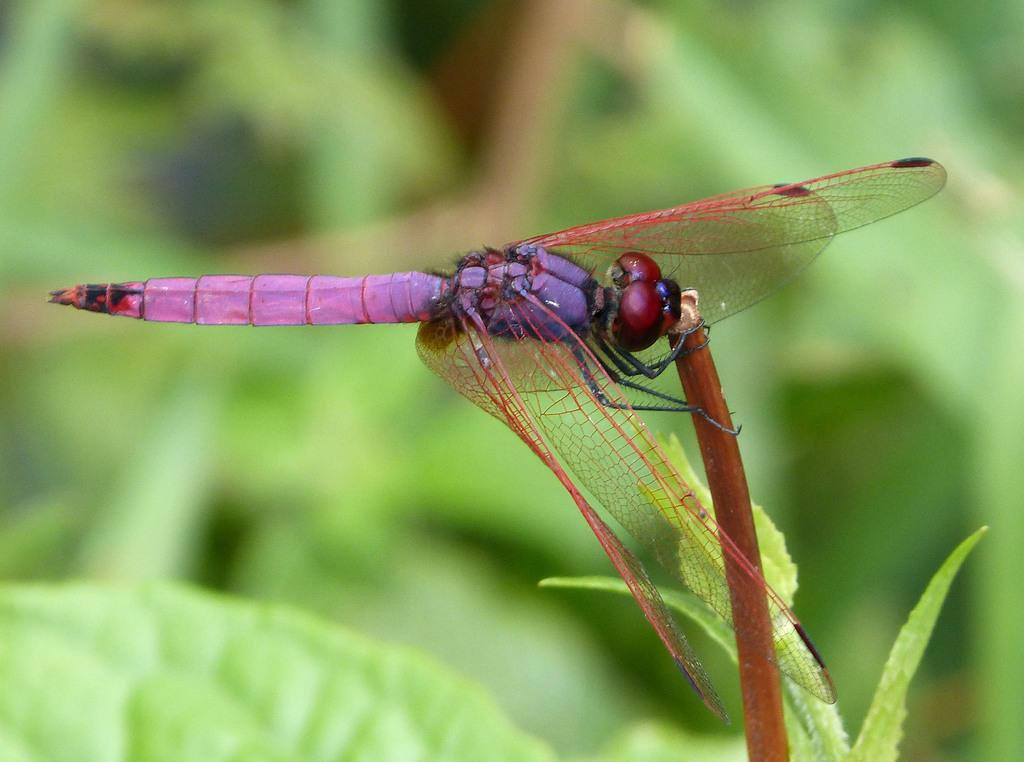What insect is present in the image? There is a dragonfly in the image. What colors can be seen on the dragonfly? The dragonfly has black, brown, and purple colors. Where is the dragonfly located in the image? The dragonfly is on a plant. How would you describe the background of the image? The background of the image is blurred. What type of match can be seen in the image? There is no match present in the image. How is the dust being used in the image? There is no dust present in the image. 